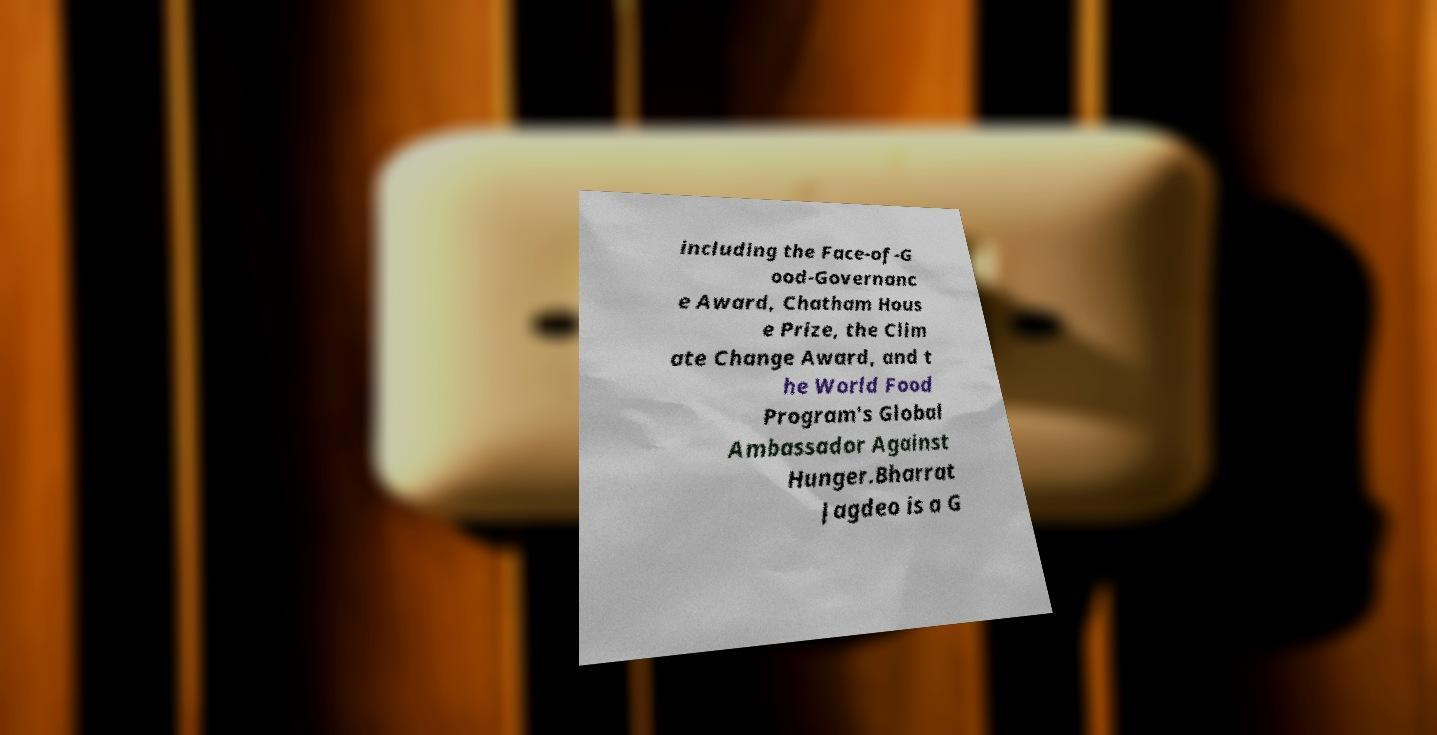What messages or text are displayed in this image? I need them in a readable, typed format. including the Face-of-G ood-Governanc e Award, Chatham Hous e Prize, the Clim ate Change Award, and t he World Food Program's Global Ambassador Against Hunger.Bharrat Jagdeo is a G 